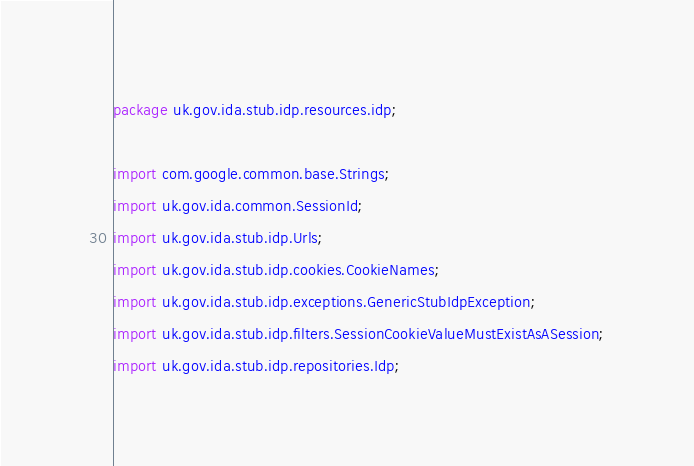<code> <loc_0><loc_0><loc_500><loc_500><_Java_>package uk.gov.ida.stub.idp.resources.idp;

import com.google.common.base.Strings;
import uk.gov.ida.common.SessionId;
import uk.gov.ida.stub.idp.Urls;
import uk.gov.ida.stub.idp.cookies.CookieNames;
import uk.gov.ida.stub.idp.exceptions.GenericStubIdpException;
import uk.gov.ida.stub.idp.filters.SessionCookieValueMustExistAsASession;
import uk.gov.ida.stub.idp.repositories.Idp;</code> 